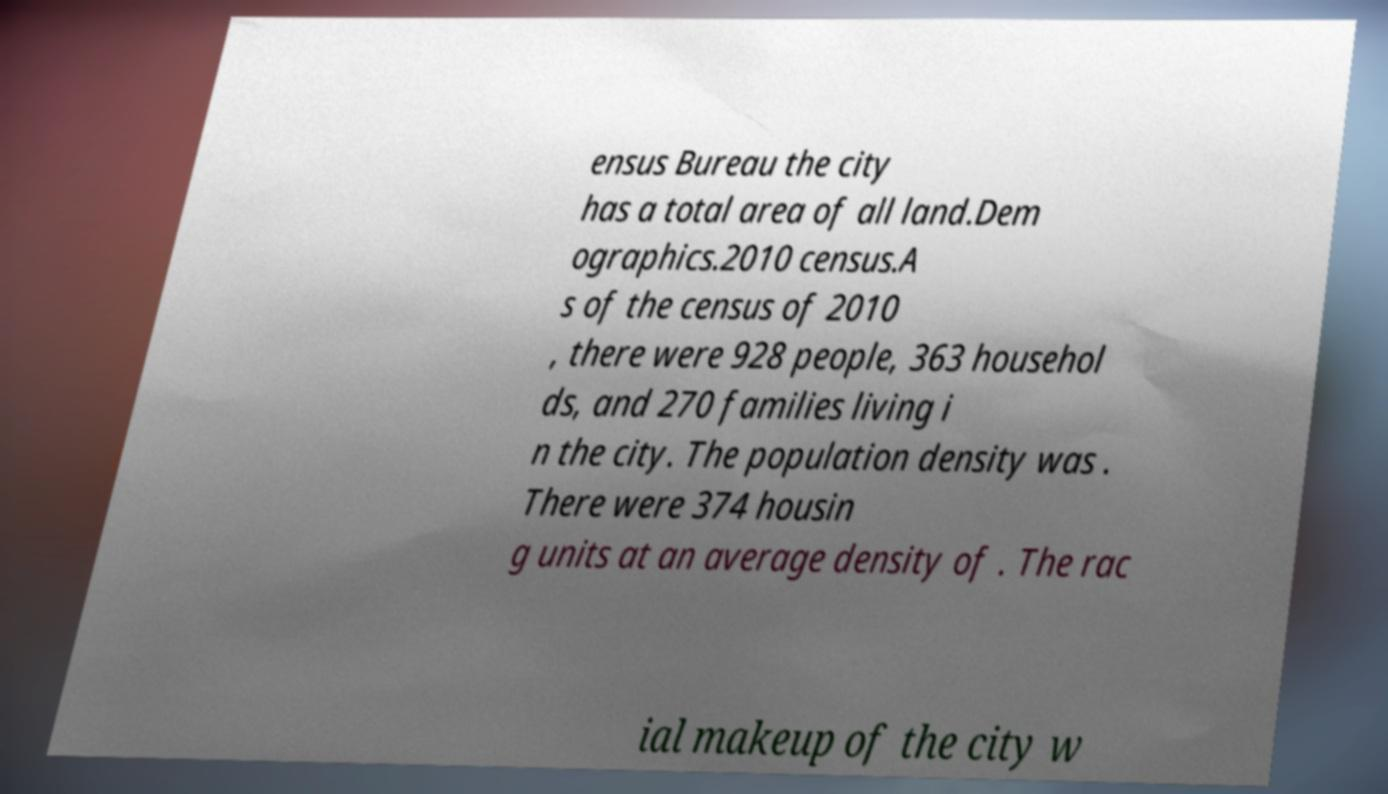Can you read and provide the text displayed in the image?This photo seems to have some interesting text. Can you extract and type it out for me? ensus Bureau the city has a total area of all land.Dem ographics.2010 census.A s of the census of 2010 , there were 928 people, 363 househol ds, and 270 families living i n the city. The population density was . There were 374 housin g units at an average density of . The rac ial makeup of the city w 